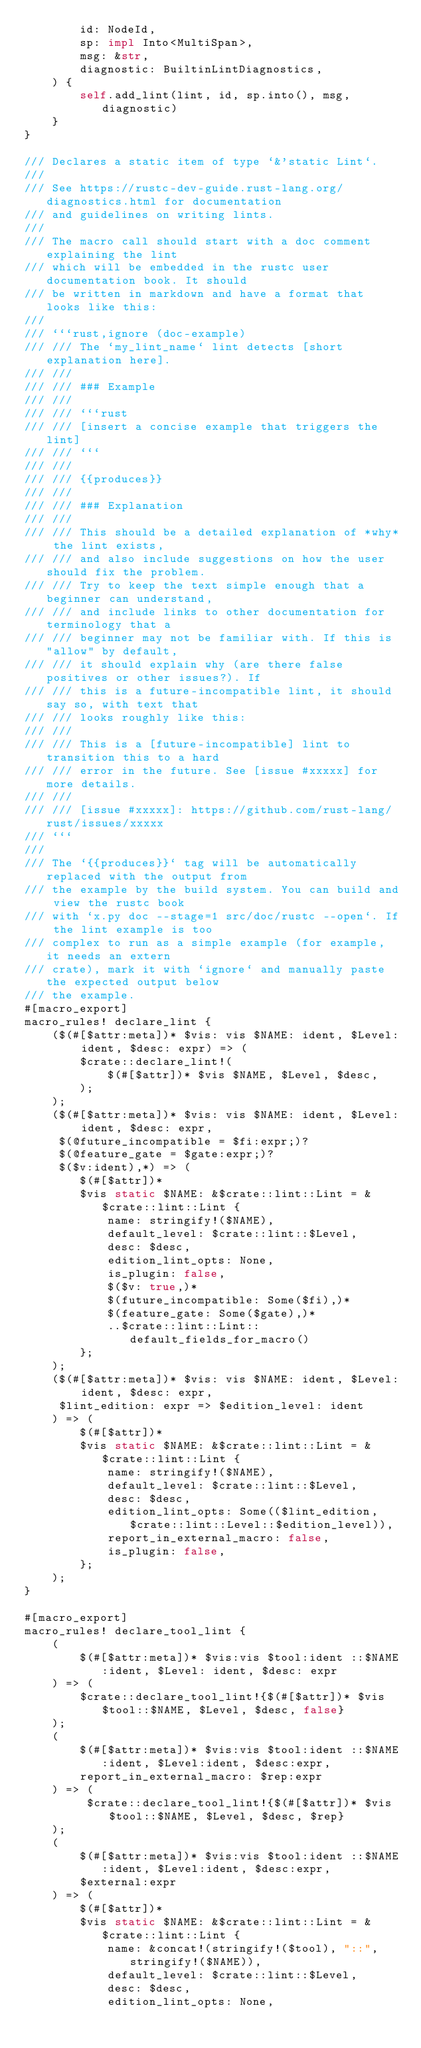Convert code to text. <code><loc_0><loc_0><loc_500><loc_500><_Rust_>        id: NodeId,
        sp: impl Into<MultiSpan>,
        msg: &str,
        diagnostic: BuiltinLintDiagnostics,
    ) {
        self.add_lint(lint, id, sp.into(), msg, diagnostic)
    }
}

/// Declares a static item of type `&'static Lint`.
///
/// See https://rustc-dev-guide.rust-lang.org/diagnostics.html for documentation
/// and guidelines on writing lints.
///
/// The macro call should start with a doc comment explaining the lint
/// which will be embedded in the rustc user documentation book. It should
/// be written in markdown and have a format that looks like this:
///
/// ```rust,ignore (doc-example)
/// /// The `my_lint_name` lint detects [short explanation here].
/// ///
/// /// ### Example
/// ///
/// /// ```rust
/// /// [insert a concise example that triggers the lint]
/// /// ```
/// ///
/// /// {{produces}}
/// ///
/// /// ### Explanation
/// ///
/// /// This should be a detailed explanation of *why* the lint exists,
/// /// and also include suggestions on how the user should fix the problem.
/// /// Try to keep the text simple enough that a beginner can understand,
/// /// and include links to other documentation for terminology that a
/// /// beginner may not be familiar with. If this is "allow" by default,
/// /// it should explain why (are there false positives or other issues?). If
/// /// this is a future-incompatible lint, it should say so, with text that
/// /// looks roughly like this:
/// ///
/// /// This is a [future-incompatible] lint to transition this to a hard
/// /// error in the future. See [issue #xxxxx] for more details.
/// ///
/// /// [issue #xxxxx]: https://github.com/rust-lang/rust/issues/xxxxx
/// ```
///
/// The `{{produces}}` tag will be automatically replaced with the output from
/// the example by the build system. You can build and view the rustc book
/// with `x.py doc --stage=1 src/doc/rustc --open`. If the lint example is too
/// complex to run as a simple example (for example, it needs an extern
/// crate), mark it with `ignore` and manually paste the expected output below
/// the example.
#[macro_export]
macro_rules! declare_lint {
    ($(#[$attr:meta])* $vis: vis $NAME: ident, $Level: ident, $desc: expr) => (
        $crate::declare_lint!(
            $(#[$attr])* $vis $NAME, $Level, $desc,
        );
    );
    ($(#[$attr:meta])* $vis: vis $NAME: ident, $Level: ident, $desc: expr,
     $(@future_incompatible = $fi:expr;)?
     $(@feature_gate = $gate:expr;)?
     $($v:ident),*) => (
        $(#[$attr])*
        $vis static $NAME: &$crate::lint::Lint = &$crate::lint::Lint {
            name: stringify!($NAME),
            default_level: $crate::lint::$Level,
            desc: $desc,
            edition_lint_opts: None,
            is_plugin: false,
            $($v: true,)*
            $(future_incompatible: Some($fi),)*
            $(feature_gate: Some($gate),)*
            ..$crate::lint::Lint::default_fields_for_macro()
        };
    );
    ($(#[$attr:meta])* $vis: vis $NAME: ident, $Level: ident, $desc: expr,
     $lint_edition: expr => $edition_level: ident
    ) => (
        $(#[$attr])*
        $vis static $NAME: &$crate::lint::Lint = &$crate::lint::Lint {
            name: stringify!($NAME),
            default_level: $crate::lint::$Level,
            desc: $desc,
            edition_lint_opts: Some(($lint_edition, $crate::lint::Level::$edition_level)),
            report_in_external_macro: false,
            is_plugin: false,
        };
    );
}

#[macro_export]
macro_rules! declare_tool_lint {
    (
        $(#[$attr:meta])* $vis:vis $tool:ident ::$NAME:ident, $Level: ident, $desc: expr
    ) => (
        $crate::declare_tool_lint!{$(#[$attr])* $vis $tool::$NAME, $Level, $desc, false}
    );
    (
        $(#[$attr:meta])* $vis:vis $tool:ident ::$NAME:ident, $Level:ident, $desc:expr,
        report_in_external_macro: $rep:expr
    ) => (
         $crate::declare_tool_lint!{$(#[$attr])* $vis $tool::$NAME, $Level, $desc, $rep}
    );
    (
        $(#[$attr:meta])* $vis:vis $tool:ident ::$NAME:ident, $Level:ident, $desc:expr,
        $external:expr
    ) => (
        $(#[$attr])*
        $vis static $NAME: &$crate::lint::Lint = &$crate::lint::Lint {
            name: &concat!(stringify!($tool), "::", stringify!($NAME)),
            default_level: $crate::lint::$Level,
            desc: $desc,
            edition_lint_opts: None,</code> 